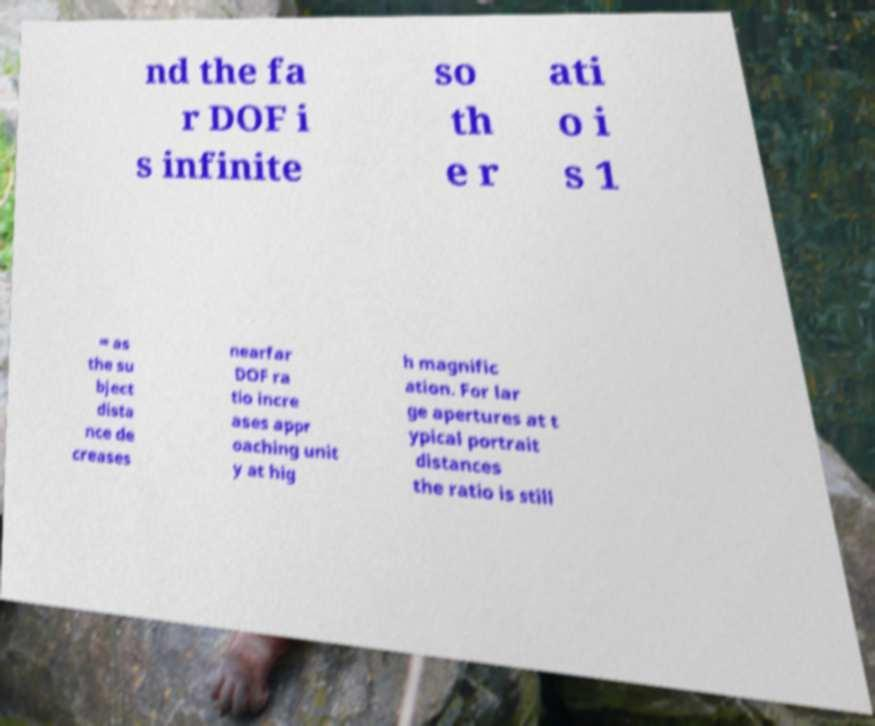Could you assist in decoding the text presented in this image and type it out clearly? nd the fa r DOF i s infinite so th e r ati o i s 1 ∞ as the su bject dista nce de creases nearfar DOF ra tio incre ases appr oaching unit y at hig h magnific ation. For lar ge apertures at t ypical portrait distances the ratio is still 